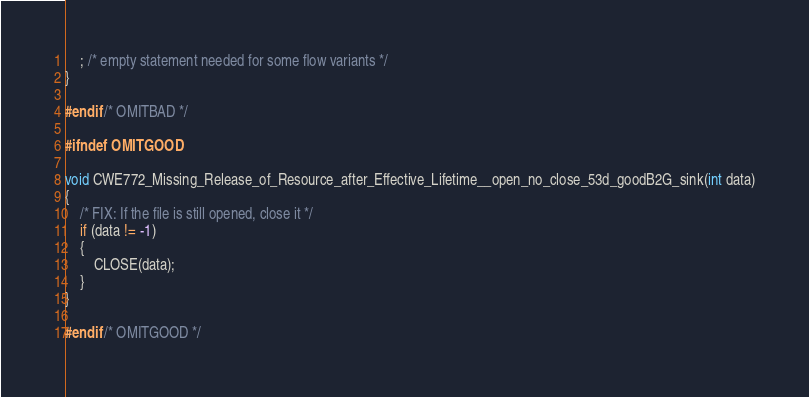<code> <loc_0><loc_0><loc_500><loc_500><_C_>    ; /* empty statement needed for some flow variants */
}

#endif /* OMITBAD */

#ifndef OMITGOOD

void CWE772_Missing_Release_of_Resource_after_Effective_Lifetime__open_no_close_53d_goodB2G_sink(int data)
{
    /* FIX: If the file is still opened, close it */
    if (data != -1)
    {
        CLOSE(data);
    }
}

#endif /* OMITGOOD */
</code> 